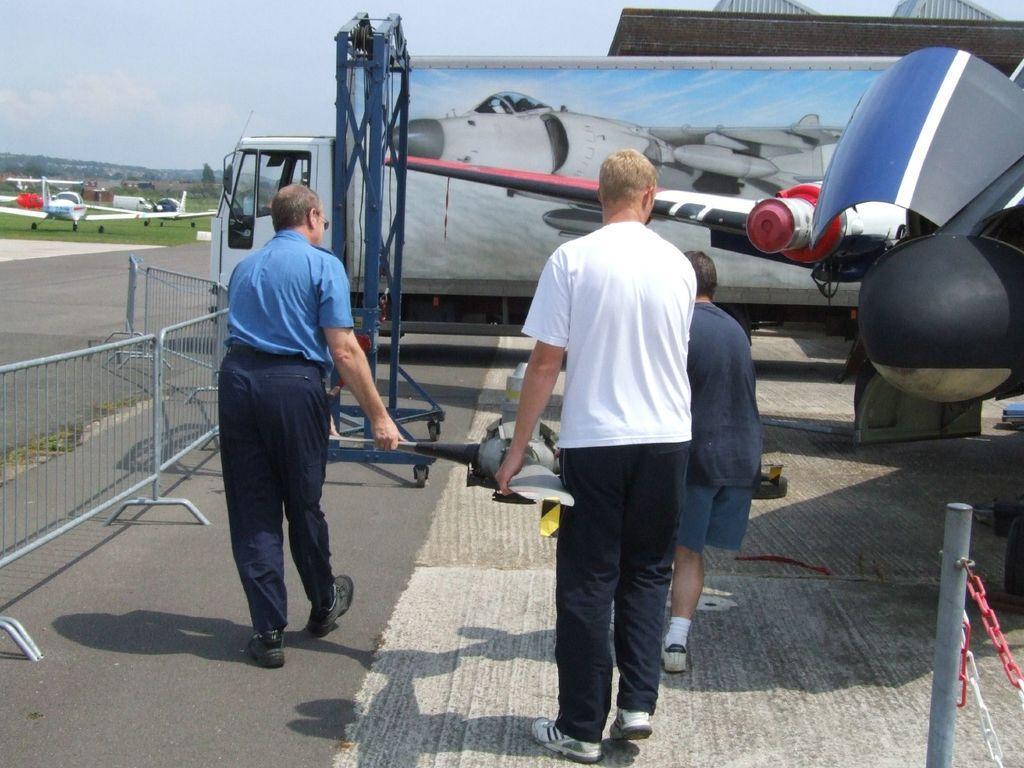Please provide a concise description of this image. In the foreground I can see three persons are holding some object in hand are walking on the road, fence and a metal stand. In the background I can see a vehicle, aircrafts, grass, trees and the sky. This image is taken may be on the road. 